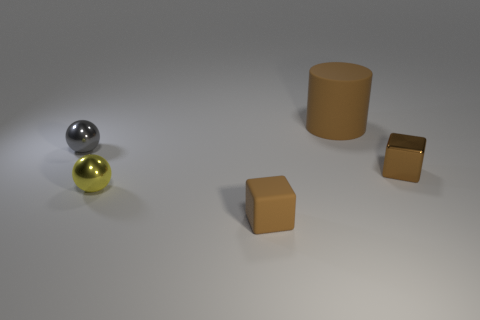How do the different objects relate to each other in composition? The composition in the image smartly uses geometric diversity and positioning to create visual interest. The cylinder, spheres, and cubes are spaced apart on a flat surface, allowing each shape to stand out while still contributing to a cohesive overall arrangement. 